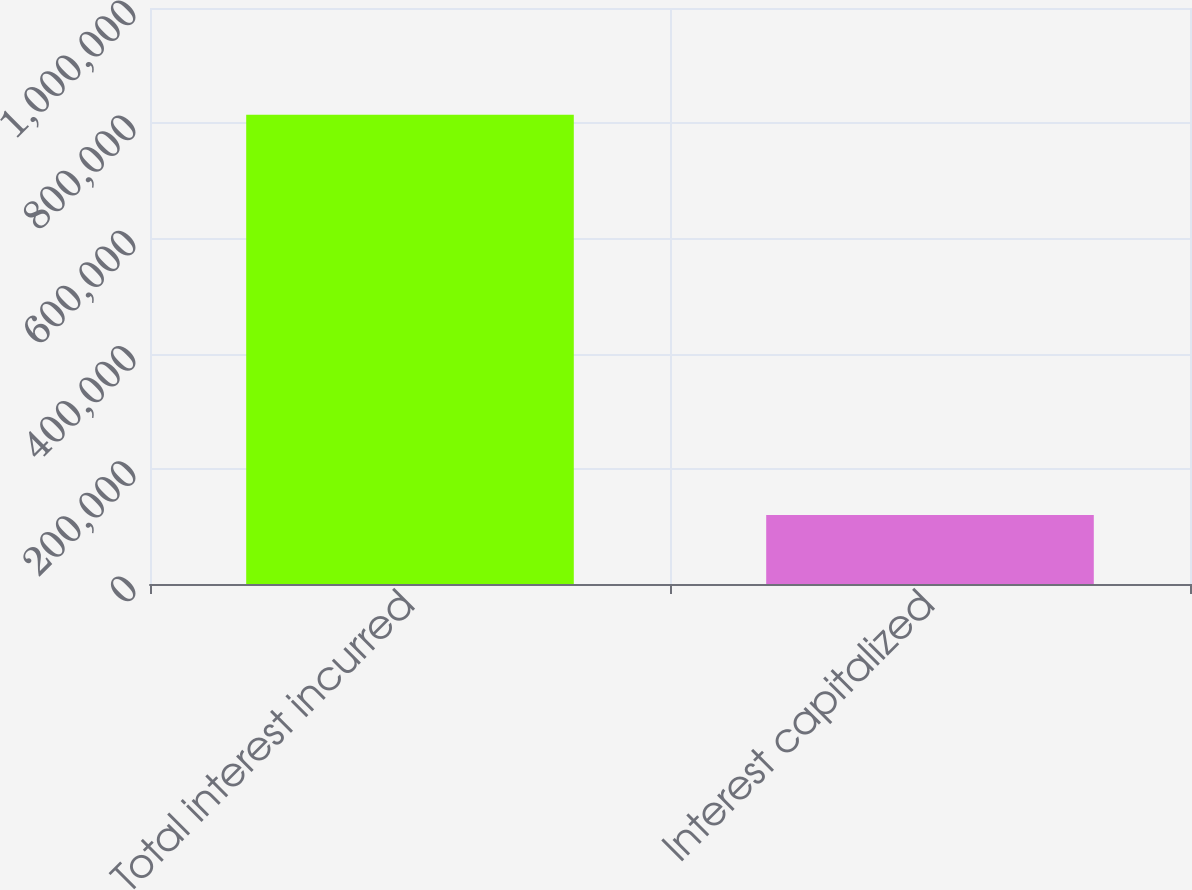Convert chart to OTSL. <chart><loc_0><loc_0><loc_500><loc_500><bar_chart><fcel>Total interest incurred<fcel>Interest capitalized<nl><fcel>814731<fcel>119958<nl></chart> 